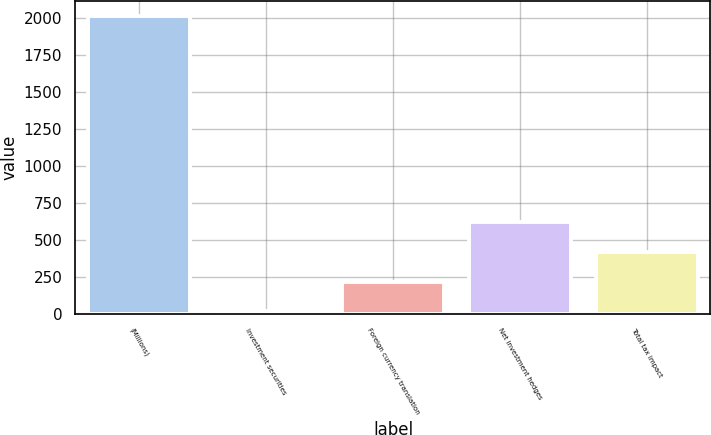Convert chart. <chart><loc_0><loc_0><loc_500><loc_500><bar_chart><fcel>(Millions)<fcel>Investment securities<fcel>Foreign currency translation<fcel>Net investment hedges<fcel>Total tax impact<nl><fcel>2014<fcel>19<fcel>218.5<fcel>617.5<fcel>418<nl></chart> 